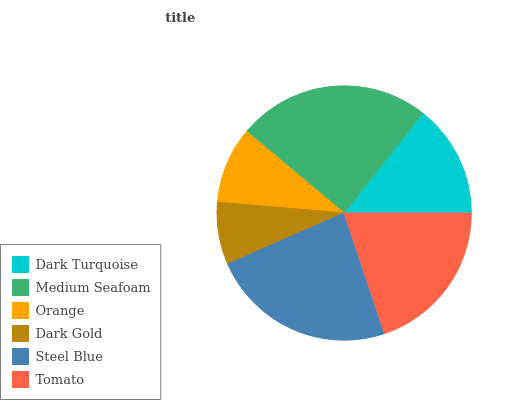Is Dark Gold the minimum?
Answer yes or no. Yes. Is Medium Seafoam the maximum?
Answer yes or no. Yes. Is Orange the minimum?
Answer yes or no. No. Is Orange the maximum?
Answer yes or no. No. Is Medium Seafoam greater than Orange?
Answer yes or no. Yes. Is Orange less than Medium Seafoam?
Answer yes or no. Yes. Is Orange greater than Medium Seafoam?
Answer yes or no. No. Is Medium Seafoam less than Orange?
Answer yes or no. No. Is Tomato the high median?
Answer yes or no. Yes. Is Dark Turquoise the low median?
Answer yes or no. Yes. Is Steel Blue the high median?
Answer yes or no. No. Is Tomato the low median?
Answer yes or no. No. 